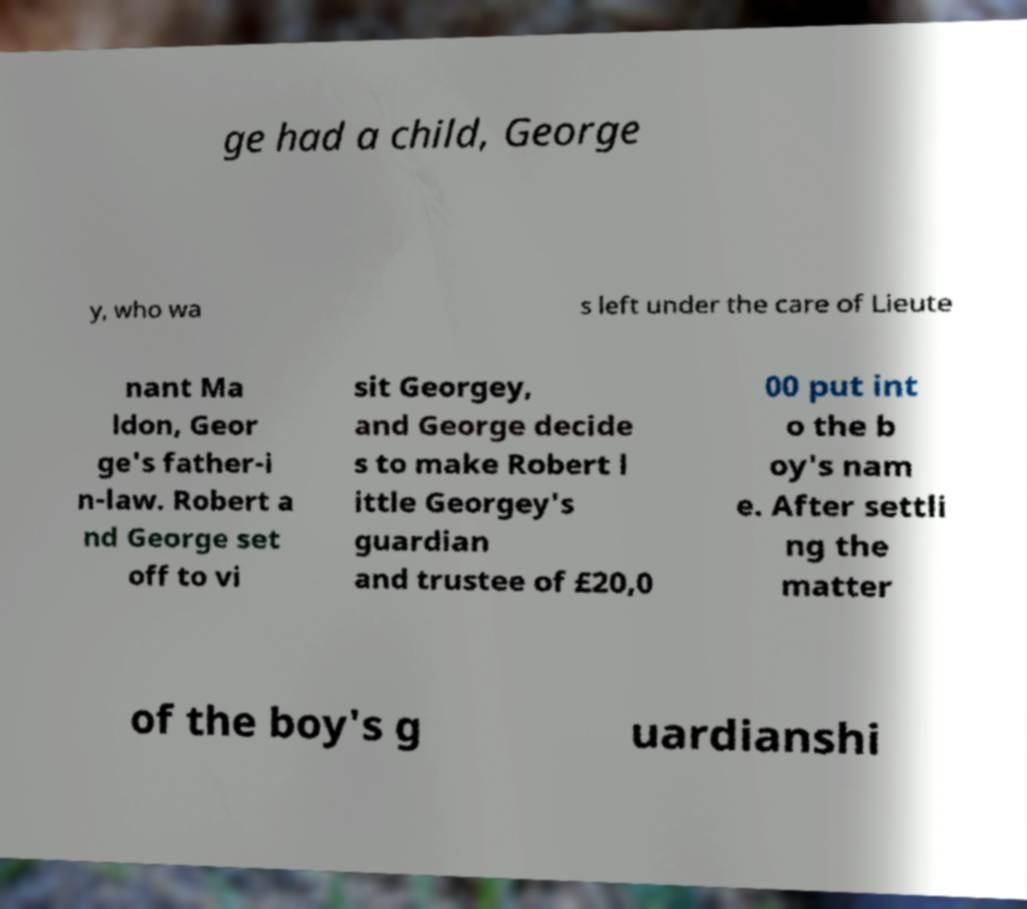Please read and relay the text visible in this image. What does it say? ge had a child, George y, who wa s left under the care of Lieute nant Ma ldon, Geor ge's father-i n-law. Robert a nd George set off to vi sit Georgey, and George decide s to make Robert l ittle Georgey's guardian and trustee of £20,0 00 put int o the b oy's nam e. After settli ng the matter of the boy's g uardianshi 